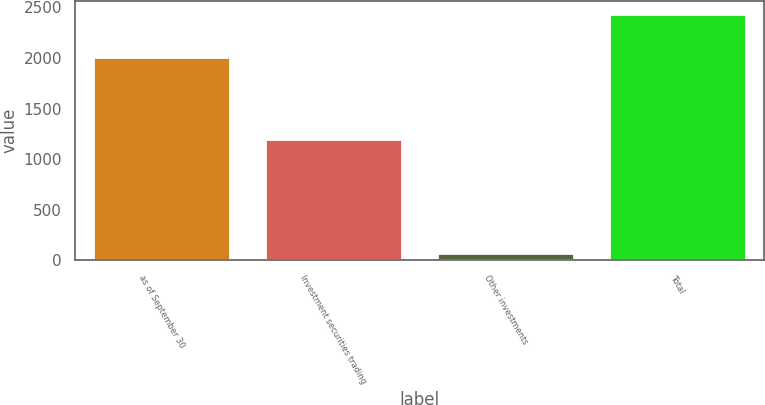Convert chart. <chart><loc_0><loc_0><loc_500><loc_500><bar_chart><fcel>as of September 30<fcel>Investment securities trading<fcel>Other investments<fcel>Total<nl><fcel>2013<fcel>1196.7<fcel>74.9<fcel>2439.2<nl></chart> 